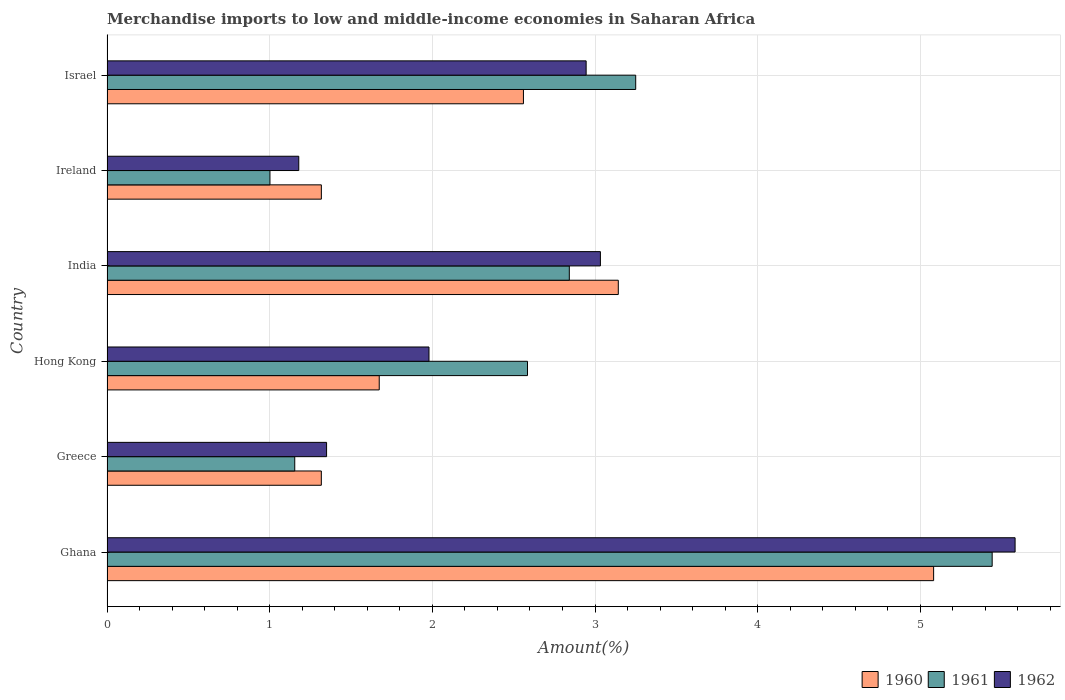Are the number of bars per tick equal to the number of legend labels?
Provide a short and direct response. Yes. Are the number of bars on each tick of the Y-axis equal?
Ensure brevity in your answer.  Yes. How many bars are there on the 1st tick from the top?
Your answer should be very brief. 3. What is the label of the 2nd group of bars from the top?
Provide a short and direct response. Ireland. What is the percentage of amount earned from merchandise imports in 1960 in Israel?
Offer a terse response. 2.56. Across all countries, what is the maximum percentage of amount earned from merchandise imports in 1960?
Provide a short and direct response. 5.08. Across all countries, what is the minimum percentage of amount earned from merchandise imports in 1962?
Your answer should be very brief. 1.18. In which country was the percentage of amount earned from merchandise imports in 1960 maximum?
Offer a very short reply. Ghana. In which country was the percentage of amount earned from merchandise imports in 1960 minimum?
Provide a short and direct response. Greece. What is the total percentage of amount earned from merchandise imports in 1962 in the graph?
Offer a very short reply. 16.07. What is the difference between the percentage of amount earned from merchandise imports in 1962 in Ghana and that in India?
Offer a very short reply. 2.55. What is the difference between the percentage of amount earned from merchandise imports in 1962 in Israel and the percentage of amount earned from merchandise imports in 1961 in Greece?
Your answer should be very brief. 1.79. What is the average percentage of amount earned from merchandise imports in 1961 per country?
Provide a succinct answer. 2.71. What is the difference between the percentage of amount earned from merchandise imports in 1960 and percentage of amount earned from merchandise imports in 1961 in Hong Kong?
Make the answer very short. -0.91. In how many countries, is the percentage of amount earned from merchandise imports in 1960 greater than 2.4 %?
Your response must be concise. 3. What is the ratio of the percentage of amount earned from merchandise imports in 1960 in Ireland to that in Israel?
Provide a succinct answer. 0.51. Is the percentage of amount earned from merchandise imports in 1962 in Greece less than that in Israel?
Give a very brief answer. Yes. Is the difference between the percentage of amount earned from merchandise imports in 1960 in Hong Kong and Ireland greater than the difference between the percentage of amount earned from merchandise imports in 1961 in Hong Kong and Ireland?
Provide a succinct answer. No. What is the difference between the highest and the second highest percentage of amount earned from merchandise imports in 1962?
Your response must be concise. 2.55. What is the difference between the highest and the lowest percentage of amount earned from merchandise imports in 1960?
Your answer should be very brief. 3.76. In how many countries, is the percentage of amount earned from merchandise imports in 1962 greater than the average percentage of amount earned from merchandise imports in 1962 taken over all countries?
Make the answer very short. 3. Is it the case that in every country, the sum of the percentage of amount earned from merchandise imports in 1960 and percentage of amount earned from merchandise imports in 1962 is greater than the percentage of amount earned from merchandise imports in 1961?
Your answer should be very brief. Yes. Are all the bars in the graph horizontal?
Give a very brief answer. Yes. Does the graph contain grids?
Give a very brief answer. Yes. How many legend labels are there?
Your response must be concise. 3. What is the title of the graph?
Your answer should be compact. Merchandise imports to low and middle-income economies in Saharan Africa. Does "1973" appear as one of the legend labels in the graph?
Offer a terse response. No. What is the label or title of the X-axis?
Provide a succinct answer. Amount(%). What is the label or title of the Y-axis?
Offer a terse response. Country. What is the Amount(%) of 1960 in Ghana?
Your answer should be compact. 5.08. What is the Amount(%) of 1961 in Ghana?
Your answer should be very brief. 5.44. What is the Amount(%) in 1962 in Ghana?
Offer a very short reply. 5.58. What is the Amount(%) in 1960 in Greece?
Provide a succinct answer. 1.32. What is the Amount(%) in 1961 in Greece?
Provide a short and direct response. 1.15. What is the Amount(%) of 1962 in Greece?
Make the answer very short. 1.35. What is the Amount(%) of 1960 in Hong Kong?
Make the answer very short. 1.67. What is the Amount(%) of 1961 in Hong Kong?
Ensure brevity in your answer.  2.58. What is the Amount(%) of 1962 in Hong Kong?
Provide a succinct answer. 1.98. What is the Amount(%) of 1960 in India?
Your answer should be very brief. 3.14. What is the Amount(%) in 1961 in India?
Provide a short and direct response. 2.84. What is the Amount(%) of 1962 in India?
Provide a succinct answer. 3.03. What is the Amount(%) in 1960 in Ireland?
Offer a very short reply. 1.32. What is the Amount(%) of 1961 in Ireland?
Your answer should be very brief. 1. What is the Amount(%) of 1962 in Ireland?
Your answer should be very brief. 1.18. What is the Amount(%) of 1960 in Israel?
Ensure brevity in your answer.  2.56. What is the Amount(%) in 1961 in Israel?
Provide a short and direct response. 3.25. What is the Amount(%) in 1962 in Israel?
Your response must be concise. 2.95. Across all countries, what is the maximum Amount(%) of 1960?
Keep it short and to the point. 5.08. Across all countries, what is the maximum Amount(%) of 1961?
Make the answer very short. 5.44. Across all countries, what is the maximum Amount(%) in 1962?
Provide a short and direct response. 5.58. Across all countries, what is the minimum Amount(%) in 1960?
Your answer should be very brief. 1.32. Across all countries, what is the minimum Amount(%) of 1961?
Offer a very short reply. 1. Across all countries, what is the minimum Amount(%) in 1962?
Your answer should be very brief. 1.18. What is the total Amount(%) of 1960 in the graph?
Make the answer very short. 15.09. What is the total Amount(%) in 1961 in the graph?
Your answer should be compact. 16.27. What is the total Amount(%) in 1962 in the graph?
Your answer should be compact. 16.07. What is the difference between the Amount(%) in 1960 in Ghana and that in Greece?
Ensure brevity in your answer.  3.76. What is the difference between the Amount(%) of 1961 in Ghana and that in Greece?
Keep it short and to the point. 4.29. What is the difference between the Amount(%) in 1962 in Ghana and that in Greece?
Provide a succinct answer. 4.23. What is the difference between the Amount(%) of 1960 in Ghana and that in Hong Kong?
Your answer should be compact. 3.41. What is the difference between the Amount(%) of 1961 in Ghana and that in Hong Kong?
Provide a succinct answer. 2.86. What is the difference between the Amount(%) in 1962 in Ghana and that in Hong Kong?
Give a very brief answer. 3.6. What is the difference between the Amount(%) of 1960 in Ghana and that in India?
Make the answer very short. 1.94. What is the difference between the Amount(%) in 1961 in Ghana and that in India?
Offer a very short reply. 2.6. What is the difference between the Amount(%) in 1962 in Ghana and that in India?
Your response must be concise. 2.55. What is the difference between the Amount(%) in 1960 in Ghana and that in Ireland?
Ensure brevity in your answer.  3.76. What is the difference between the Amount(%) of 1961 in Ghana and that in Ireland?
Provide a short and direct response. 4.44. What is the difference between the Amount(%) of 1962 in Ghana and that in Ireland?
Provide a succinct answer. 4.4. What is the difference between the Amount(%) in 1960 in Ghana and that in Israel?
Make the answer very short. 2.52. What is the difference between the Amount(%) in 1961 in Ghana and that in Israel?
Provide a succinct answer. 2.19. What is the difference between the Amount(%) in 1962 in Ghana and that in Israel?
Offer a very short reply. 2.64. What is the difference between the Amount(%) of 1960 in Greece and that in Hong Kong?
Make the answer very short. -0.36. What is the difference between the Amount(%) of 1961 in Greece and that in Hong Kong?
Your answer should be very brief. -1.43. What is the difference between the Amount(%) in 1962 in Greece and that in Hong Kong?
Your answer should be compact. -0.63. What is the difference between the Amount(%) of 1960 in Greece and that in India?
Provide a short and direct response. -1.83. What is the difference between the Amount(%) of 1961 in Greece and that in India?
Your answer should be compact. -1.69. What is the difference between the Amount(%) of 1962 in Greece and that in India?
Ensure brevity in your answer.  -1.68. What is the difference between the Amount(%) of 1960 in Greece and that in Ireland?
Give a very brief answer. -0. What is the difference between the Amount(%) in 1961 in Greece and that in Ireland?
Provide a short and direct response. 0.15. What is the difference between the Amount(%) of 1962 in Greece and that in Ireland?
Make the answer very short. 0.17. What is the difference between the Amount(%) in 1960 in Greece and that in Israel?
Offer a very short reply. -1.24. What is the difference between the Amount(%) in 1961 in Greece and that in Israel?
Ensure brevity in your answer.  -2.1. What is the difference between the Amount(%) in 1962 in Greece and that in Israel?
Provide a short and direct response. -1.6. What is the difference between the Amount(%) in 1960 in Hong Kong and that in India?
Your response must be concise. -1.47. What is the difference between the Amount(%) of 1961 in Hong Kong and that in India?
Provide a short and direct response. -0.26. What is the difference between the Amount(%) of 1962 in Hong Kong and that in India?
Provide a short and direct response. -1.05. What is the difference between the Amount(%) of 1960 in Hong Kong and that in Ireland?
Offer a terse response. 0.36. What is the difference between the Amount(%) in 1961 in Hong Kong and that in Ireland?
Your answer should be very brief. 1.58. What is the difference between the Amount(%) of 1962 in Hong Kong and that in Ireland?
Your response must be concise. 0.8. What is the difference between the Amount(%) in 1960 in Hong Kong and that in Israel?
Provide a short and direct response. -0.89. What is the difference between the Amount(%) in 1961 in Hong Kong and that in Israel?
Keep it short and to the point. -0.67. What is the difference between the Amount(%) in 1962 in Hong Kong and that in Israel?
Your answer should be very brief. -0.97. What is the difference between the Amount(%) of 1960 in India and that in Ireland?
Give a very brief answer. 1.83. What is the difference between the Amount(%) in 1961 in India and that in Ireland?
Give a very brief answer. 1.84. What is the difference between the Amount(%) in 1962 in India and that in Ireland?
Provide a succinct answer. 1.85. What is the difference between the Amount(%) of 1960 in India and that in Israel?
Your response must be concise. 0.58. What is the difference between the Amount(%) in 1961 in India and that in Israel?
Provide a short and direct response. -0.41. What is the difference between the Amount(%) in 1962 in India and that in Israel?
Give a very brief answer. 0.09. What is the difference between the Amount(%) of 1960 in Ireland and that in Israel?
Offer a very short reply. -1.24. What is the difference between the Amount(%) of 1961 in Ireland and that in Israel?
Your answer should be compact. -2.25. What is the difference between the Amount(%) in 1962 in Ireland and that in Israel?
Offer a terse response. -1.77. What is the difference between the Amount(%) in 1960 in Ghana and the Amount(%) in 1961 in Greece?
Your answer should be compact. 3.93. What is the difference between the Amount(%) in 1960 in Ghana and the Amount(%) in 1962 in Greece?
Give a very brief answer. 3.73. What is the difference between the Amount(%) in 1961 in Ghana and the Amount(%) in 1962 in Greece?
Offer a very short reply. 4.09. What is the difference between the Amount(%) of 1960 in Ghana and the Amount(%) of 1961 in Hong Kong?
Provide a succinct answer. 2.5. What is the difference between the Amount(%) of 1960 in Ghana and the Amount(%) of 1962 in Hong Kong?
Provide a short and direct response. 3.1. What is the difference between the Amount(%) in 1961 in Ghana and the Amount(%) in 1962 in Hong Kong?
Keep it short and to the point. 3.46. What is the difference between the Amount(%) of 1960 in Ghana and the Amount(%) of 1961 in India?
Keep it short and to the point. 2.24. What is the difference between the Amount(%) of 1960 in Ghana and the Amount(%) of 1962 in India?
Offer a very short reply. 2.05. What is the difference between the Amount(%) in 1961 in Ghana and the Amount(%) in 1962 in India?
Make the answer very short. 2.41. What is the difference between the Amount(%) in 1960 in Ghana and the Amount(%) in 1961 in Ireland?
Offer a terse response. 4.08. What is the difference between the Amount(%) of 1960 in Ghana and the Amount(%) of 1962 in Ireland?
Provide a succinct answer. 3.9. What is the difference between the Amount(%) of 1961 in Ghana and the Amount(%) of 1962 in Ireland?
Ensure brevity in your answer.  4.26. What is the difference between the Amount(%) of 1960 in Ghana and the Amount(%) of 1961 in Israel?
Give a very brief answer. 1.83. What is the difference between the Amount(%) of 1960 in Ghana and the Amount(%) of 1962 in Israel?
Make the answer very short. 2.14. What is the difference between the Amount(%) of 1961 in Ghana and the Amount(%) of 1962 in Israel?
Your answer should be very brief. 2.5. What is the difference between the Amount(%) of 1960 in Greece and the Amount(%) of 1961 in Hong Kong?
Give a very brief answer. -1.27. What is the difference between the Amount(%) in 1960 in Greece and the Amount(%) in 1962 in Hong Kong?
Make the answer very short. -0.66. What is the difference between the Amount(%) of 1961 in Greece and the Amount(%) of 1962 in Hong Kong?
Ensure brevity in your answer.  -0.83. What is the difference between the Amount(%) of 1960 in Greece and the Amount(%) of 1961 in India?
Your answer should be compact. -1.52. What is the difference between the Amount(%) of 1960 in Greece and the Amount(%) of 1962 in India?
Keep it short and to the point. -1.72. What is the difference between the Amount(%) in 1961 in Greece and the Amount(%) in 1962 in India?
Your answer should be compact. -1.88. What is the difference between the Amount(%) of 1960 in Greece and the Amount(%) of 1961 in Ireland?
Offer a very short reply. 0.32. What is the difference between the Amount(%) in 1960 in Greece and the Amount(%) in 1962 in Ireland?
Offer a terse response. 0.14. What is the difference between the Amount(%) in 1961 in Greece and the Amount(%) in 1962 in Ireland?
Your answer should be compact. -0.02. What is the difference between the Amount(%) in 1960 in Greece and the Amount(%) in 1961 in Israel?
Your answer should be compact. -1.93. What is the difference between the Amount(%) in 1960 in Greece and the Amount(%) in 1962 in Israel?
Keep it short and to the point. -1.63. What is the difference between the Amount(%) in 1961 in Greece and the Amount(%) in 1962 in Israel?
Provide a succinct answer. -1.79. What is the difference between the Amount(%) in 1960 in Hong Kong and the Amount(%) in 1961 in India?
Keep it short and to the point. -1.17. What is the difference between the Amount(%) of 1960 in Hong Kong and the Amount(%) of 1962 in India?
Your answer should be compact. -1.36. What is the difference between the Amount(%) of 1961 in Hong Kong and the Amount(%) of 1962 in India?
Offer a terse response. -0.45. What is the difference between the Amount(%) of 1960 in Hong Kong and the Amount(%) of 1961 in Ireland?
Ensure brevity in your answer.  0.67. What is the difference between the Amount(%) of 1960 in Hong Kong and the Amount(%) of 1962 in Ireland?
Your answer should be compact. 0.49. What is the difference between the Amount(%) of 1961 in Hong Kong and the Amount(%) of 1962 in Ireland?
Your response must be concise. 1.41. What is the difference between the Amount(%) in 1960 in Hong Kong and the Amount(%) in 1961 in Israel?
Your answer should be very brief. -1.58. What is the difference between the Amount(%) in 1960 in Hong Kong and the Amount(%) in 1962 in Israel?
Your answer should be compact. -1.27. What is the difference between the Amount(%) in 1961 in Hong Kong and the Amount(%) in 1962 in Israel?
Your answer should be compact. -0.36. What is the difference between the Amount(%) in 1960 in India and the Amount(%) in 1961 in Ireland?
Your response must be concise. 2.14. What is the difference between the Amount(%) of 1960 in India and the Amount(%) of 1962 in Ireland?
Provide a succinct answer. 1.96. What is the difference between the Amount(%) of 1961 in India and the Amount(%) of 1962 in Ireland?
Your answer should be very brief. 1.66. What is the difference between the Amount(%) in 1960 in India and the Amount(%) in 1961 in Israel?
Offer a terse response. -0.11. What is the difference between the Amount(%) of 1960 in India and the Amount(%) of 1962 in Israel?
Ensure brevity in your answer.  0.2. What is the difference between the Amount(%) in 1961 in India and the Amount(%) in 1962 in Israel?
Give a very brief answer. -0.1. What is the difference between the Amount(%) of 1960 in Ireland and the Amount(%) of 1961 in Israel?
Offer a terse response. -1.93. What is the difference between the Amount(%) in 1960 in Ireland and the Amount(%) in 1962 in Israel?
Offer a terse response. -1.63. What is the difference between the Amount(%) of 1961 in Ireland and the Amount(%) of 1962 in Israel?
Ensure brevity in your answer.  -1.94. What is the average Amount(%) of 1960 per country?
Ensure brevity in your answer.  2.52. What is the average Amount(%) in 1961 per country?
Give a very brief answer. 2.71. What is the average Amount(%) in 1962 per country?
Keep it short and to the point. 2.68. What is the difference between the Amount(%) of 1960 and Amount(%) of 1961 in Ghana?
Your response must be concise. -0.36. What is the difference between the Amount(%) in 1960 and Amount(%) in 1962 in Ghana?
Offer a very short reply. -0.5. What is the difference between the Amount(%) of 1961 and Amount(%) of 1962 in Ghana?
Keep it short and to the point. -0.14. What is the difference between the Amount(%) of 1960 and Amount(%) of 1961 in Greece?
Give a very brief answer. 0.16. What is the difference between the Amount(%) of 1960 and Amount(%) of 1962 in Greece?
Offer a terse response. -0.03. What is the difference between the Amount(%) in 1961 and Amount(%) in 1962 in Greece?
Provide a succinct answer. -0.2. What is the difference between the Amount(%) of 1960 and Amount(%) of 1961 in Hong Kong?
Your answer should be very brief. -0.91. What is the difference between the Amount(%) of 1960 and Amount(%) of 1962 in Hong Kong?
Offer a terse response. -0.31. What is the difference between the Amount(%) in 1961 and Amount(%) in 1962 in Hong Kong?
Make the answer very short. 0.61. What is the difference between the Amount(%) of 1960 and Amount(%) of 1961 in India?
Keep it short and to the point. 0.3. What is the difference between the Amount(%) of 1960 and Amount(%) of 1962 in India?
Provide a succinct answer. 0.11. What is the difference between the Amount(%) in 1961 and Amount(%) in 1962 in India?
Provide a short and direct response. -0.19. What is the difference between the Amount(%) in 1960 and Amount(%) in 1961 in Ireland?
Your response must be concise. 0.32. What is the difference between the Amount(%) of 1960 and Amount(%) of 1962 in Ireland?
Offer a terse response. 0.14. What is the difference between the Amount(%) in 1961 and Amount(%) in 1962 in Ireland?
Your answer should be compact. -0.18. What is the difference between the Amount(%) in 1960 and Amount(%) in 1961 in Israel?
Make the answer very short. -0.69. What is the difference between the Amount(%) in 1960 and Amount(%) in 1962 in Israel?
Offer a very short reply. -0.39. What is the difference between the Amount(%) in 1961 and Amount(%) in 1962 in Israel?
Provide a short and direct response. 0.3. What is the ratio of the Amount(%) in 1960 in Ghana to that in Greece?
Provide a short and direct response. 3.86. What is the ratio of the Amount(%) of 1961 in Ghana to that in Greece?
Provide a short and direct response. 4.71. What is the ratio of the Amount(%) of 1962 in Ghana to that in Greece?
Your answer should be very brief. 4.14. What is the ratio of the Amount(%) in 1960 in Ghana to that in Hong Kong?
Offer a very short reply. 3.04. What is the ratio of the Amount(%) of 1961 in Ghana to that in Hong Kong?
Keep it short and to the point. 2.1. What is the ratio of the Amount(%) of 1962 in Ghana to that in Hong Kong?
Your response must be concise. 2.82. What is the ratio of the Amount(%) in 1960 in Ghana to that in India?
Provide a short and direct response. 1.62. What is the ratio of the Amount(%) in 1961 in Ghana to that in India?
Give a very brief answer. 1.91. What is the ratio of the Amount(%) in 1962 in Ghana to that in India?
Offer a terse response. 1.84. What is the ratio of the Amount(%) in 1960 in Ghana to that in Ireland?
Keep it short and to the point. 3.86. What is the ratio of the Amount(%) in 1961 in Ghana to that in Ireland?
Give a very brief answer. 5.43. What is the ratio of the Amount(%) in 1962 in Ghana to that in Ireland?
Provide a succinct answer. 4.74. What is the ratio of the Amount(%) in 1960 in Ghana to that in Israel?
Provide a succinct answer. 1.99. What is the ratio of the Amount(%) of 1961 in Ghana to that in Israel?
Your answer should be compact. 1.67. What is the ratio of the Amount(%) in 1962 in Ghana to that in Israel?
Your answer should be compact. 1.9. What is the ratio of the Amount(%) of 1960 in Greece to that in Hong Kong?
Your response must be concise. 0.79. What is the ratio of the Amount(%) of 1961 in Greece to that in Hong Kong?
Offer a terse response. 0.45. What is the ratio of the Amount(%) in 1962 in Greece to that in Hong Kong?
Give a very brief answer. 0.68. What is the ratio of the Amount(%) of 1960 in Greece to that in India?
Make the answer very short. 0.42. What is the ratio of the Amount(%) of 1961 in Greece to that in India?
Provide a short and direct response. 0.41. What is the ratio of the Amount(%) of 1962 in Greece to that in India?
Ensure brevity in your answer.  0.45. What is the ratio of the Amount(%) in 1961 in Greece to that in Ireland?
Give a very brief answer. 1.15. What is the ratio of the Amount(%) in 1962 in Greece to that in Ireland?
Provide a succinct answer. 1.15. What is the ratio of the Amount(%) in 1960 in Greece to that in Israel?
Give a very brief answer. 0.51. What is the ratio of the Amount(%) of 1961 in Greece to that in Israel?
Make the answer very short. 0.36. What is the ratio of the Amount(%) in 1962 in Greece to that in Israel?
Provide a short and direct response. 0.46. What is the ratio of the Amount(%) of 1960 in Hong Kong to that in India?
Provide a succinct answer. 0.53. What is the ratio of the Amount(%) of 1961 in Hong Kong to that in India?
Your answer should be compact. 0.91. What is the ratio of the Amount(%) of 1962 in Hong Kong to that in India?
Ensure brevity in your answer.  0.65. What is the ratio of the Amount(%) of 1960 in Hong Kong to that in Ireland?
Keep it short and to the point. 1.27. What is the ratio of the Amount(%) of 1961 in Hong Kong to that in Ireland?
Your answer should be very brief. 2.58. What is the ratio of the Amount(%) in 1962 in Hong Kong to that in Ireland?
Keep it short and to the point. 1.68. What is the ratio of the Amount(%) of 1960 in Hong Kong to that in Israel?
Ensure brevity in your answer.  0.65. What is the ratio of the Amount(%) in 1961 in Hong Kong to that in Israel?
Your response must be concise. 0.8. What is the ratio of the Amount(%) in 1962 in Hong Kong to that in Israel?
Keep it short and to the point. 0.67. What is the ratio of the Amount(%) of 1960 in India to that in Ireland?
Offer a very short reply. 2.39. What is the ratio of the Amount(%) in 1961 in India to that in Ireland?
Ensure brevity in your answer.  2.84. What is the ratio of the Amount(%) in 1962 in India to that in Ireland?
Your answer should be compact. 2.57. What is the ratio of the Amount(%) in 1960 in India to that in Israel?
Your answer should be very brief. 1.23. What is the ratio of the Amount(%) of 1961 in India to that in Israel?
Ensure brevity in your answer.  0.87. What is the ratio of the Amount(%) of 1962 in India to that in Israel?
Offer a very short reply. 1.03. What is the ratio of the Amount(%) in 1960 in Ireland to that in Israel?
Make the answer very short. 0.51. What is the ratio of the Amount(%) of 1961 in Ireland to that in Israel?
Offer a terse response. 0.31. What is the ratio of the Amount(%) of 1962 in Ireland to that in Israel?
Give a very brief answer. 0.4. What is the difference between the highest and the second highest Amount(%) of 1960?
Make the answer very short. 1.94. What is the difference between the highest and the second highest Amount(%) of 1961?
Your answer should be very brief. 2.19. What is the difference between the highest and the second highest Amount(%) of 1962?
Provide a short and direct response. 2.55. What is the difference between the highest and the lowest Amount(%) of 1960?
Your answer should be very brief. 3.76. What is the difference between the highest and the lowest Amount(%) of 1961?
Make the answer very short. 4.44. What is the difference between the highest and the lowest Amount(%) in 1962?
Offer a very short reply. 4.4. 